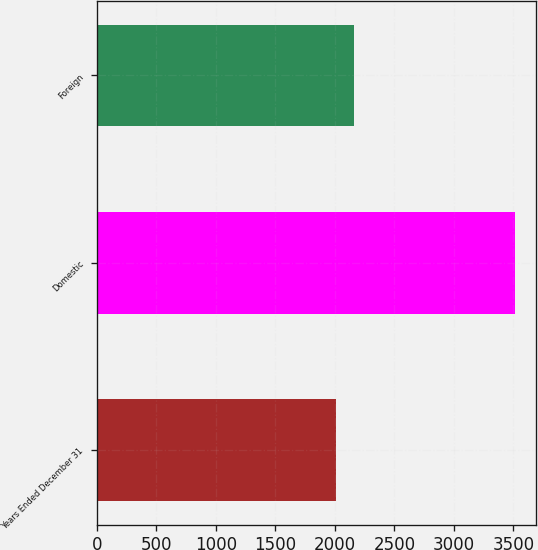Convert chart. <chart><loc_0><loc_0><loc_500><loc_500><bar_chart><fcel>Years Ended December 31<fcel>Domestic<fcel>Foreign<nl><fcel>2013<fcel>3513<fcel>2163<nl></chart> 